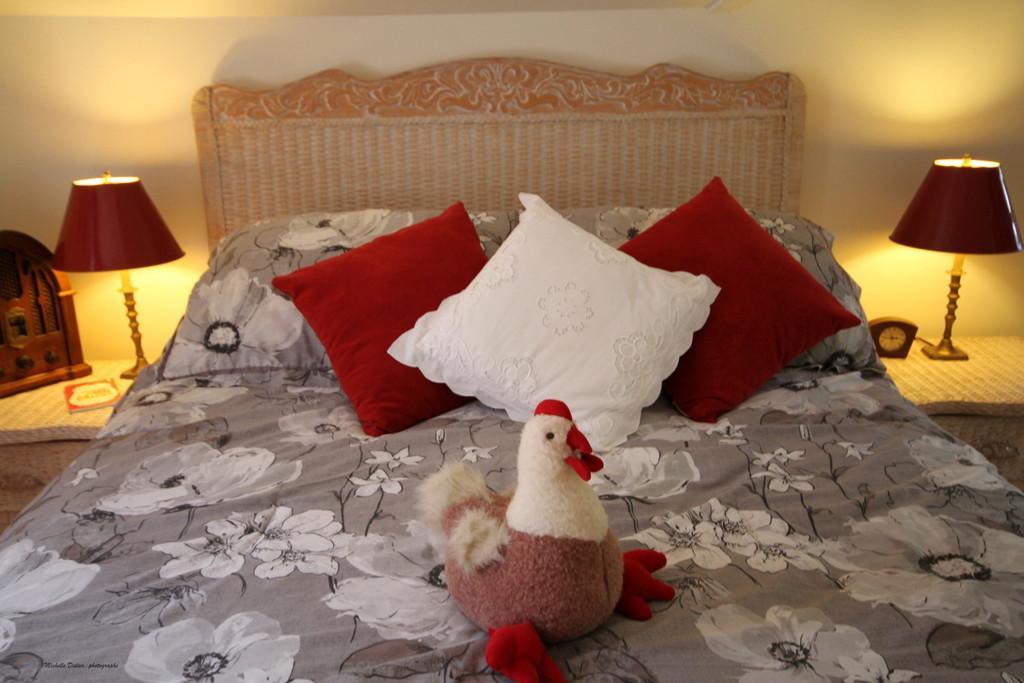Describe this image in one or two sentences. In this image, we can see bed, pillows, cushions. And there is a tables on the right side and left side, Few items are placed on it. Background, there is a wall. In the middle of the image, we can see some toy. 